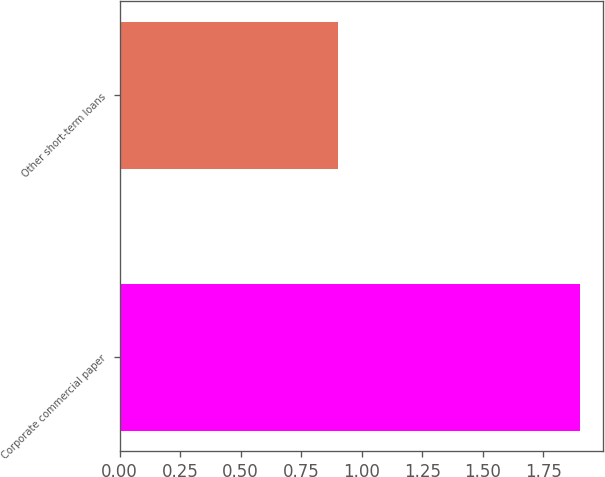Convert chart to OTSL. <chart><loc_0><loc_0><loc_500><loc_500><bar_chart><fcel>Corporate commercial paper<fcel>Other short-term loans<nl><fcel>1.9<fcel>0.9<nl></chart> 